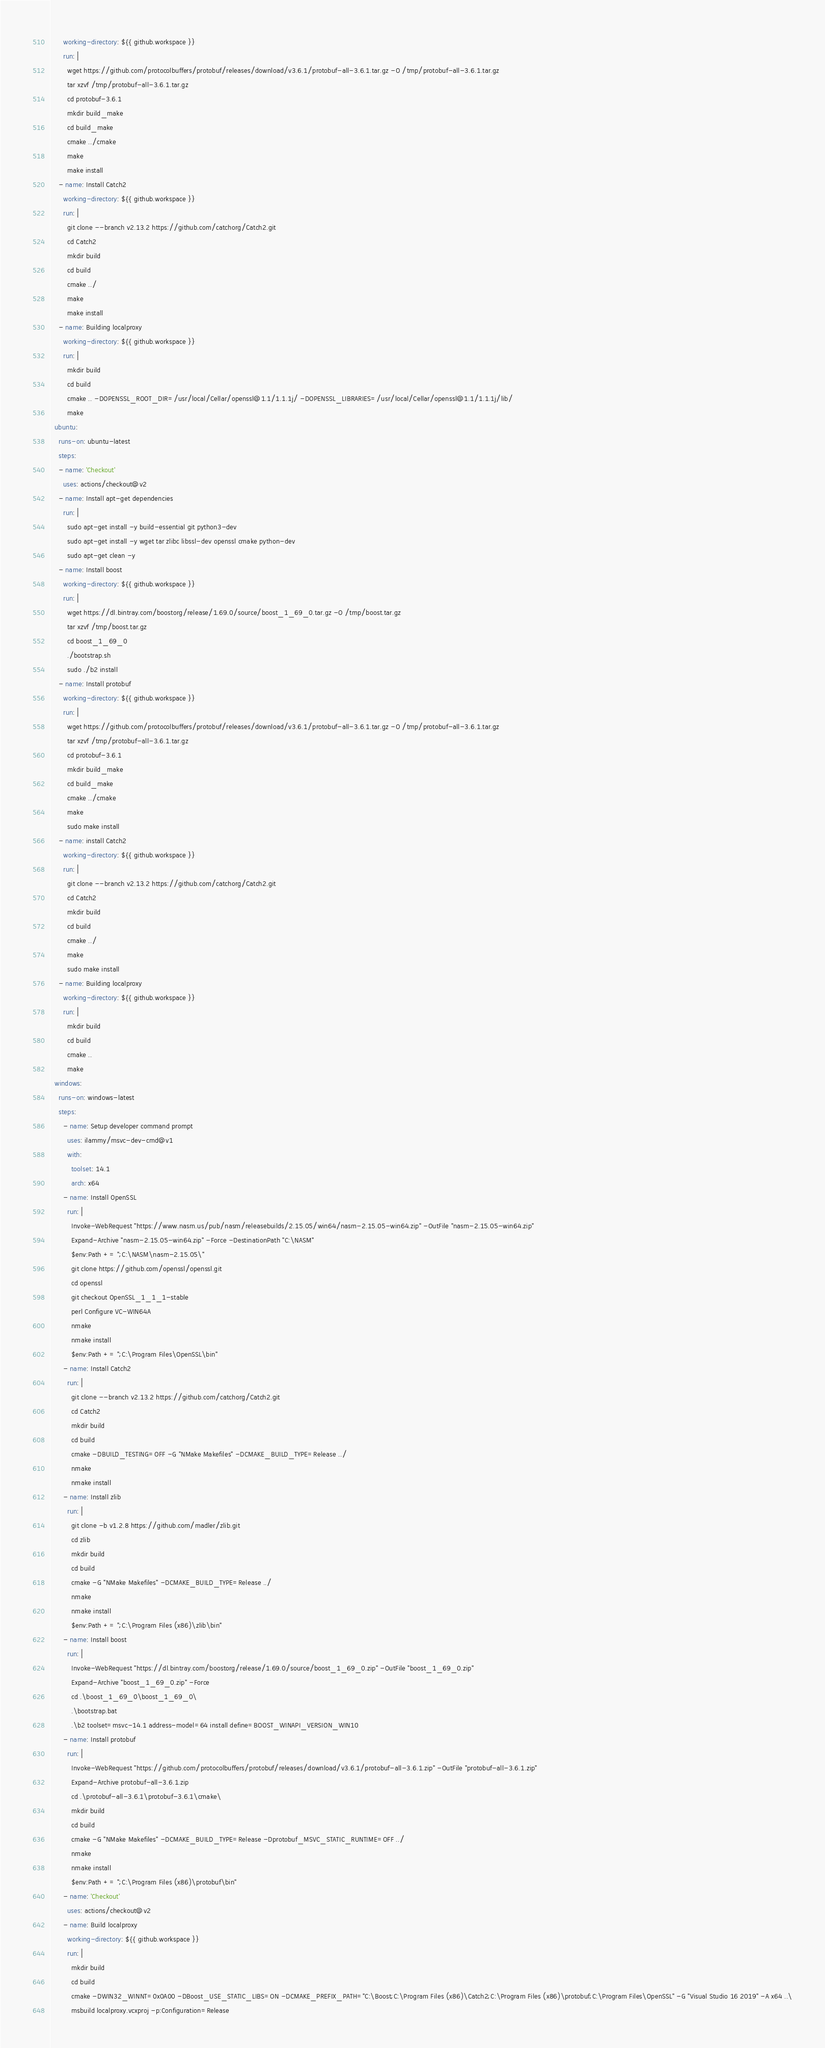Convert code to text. <code><loc_0><loc_0><loc_500><loc_500><_YAML_>      working-directory: ${{ github.workspace }}
      run: |
        wget https://github.com/protocolbuffers/protobuf/releases/download/v3.6.1/protobuf-all-3.6.1.tar.gz -O /tmp/protobuf-all-3.6.1.tar.gz
        tar xzvf /tmp/protobuf-all-3.6.1.tar.gz
        cd protobuf-3.6.1
        mkdir build_make
        cd build_make
        cmake ../cmake
        make
        make install
    - name: Install Catch2
      working-directory: ${{ github.workspace }}
      run: |
        git clone --branch v2.13.2 https://github.com/catchorg/Catch2.git
        cd Catch2
        mkdir build
        cd build
        cmake ../
        make
        make install
    - name: Building localproxy
      working-directory: ${{ github.workspace }}
      run: |
        mkdir build
        cd build
        cmake .. -DOPENSSL_ROOT_DIR=/usr/local/Cellar/openssl@1.1/1.1.1j/ -DOPENSSL_LIBRARIES=/usr/local/Cellar/openssl@1.1/1.1.1j/lib/
        make
  ubuntu:
    runs-on: ubuntu-latest
    steps:
    - name: 'Checkout'
      uses: actions/checkout@v2
    - name: Install apt-get dependencies
      run: |
        sudo apt-get install -y build-essential git python3-dev
        sudo apt-get install -y wget tar zlibc libssl-dev openssl cmake python-dev
        sudo apt-get clean -y
    - name: Install boost
      working-directory: ${{ github.workspace }}
      run: |
        wget https://dl.bintray.com/boostorg/release/1.69.0/source/boost_1_69_0.tar.gz -O /tmp/boost.tar.gz
        tar xzvf /tmp/boost.tar.gz
        cd boost_1_69_0
        ./bootstrap.sh
        sudo ./b2 install
    - name: Install protobuf
      working-directory: ${{ github.workspace }}
      run: |
        wget https://github.com/protocolbuffers/protobuf/releases/download/v3.6.1/protobuf-all-3.6.1.tar.gz -O /tmp/protobuf-all-3.6.1.tar.gz
        tar xzvf /tmp/protobuf-all-3.6.1.tar.gz
        cd protobuf-3.6.1
        mkdir build_make
        cd build_make
        cmake ../cmake
        make
        sudo make install
    - name: install Catch2
      working-directory: ${{ github.workspace }}
      run: |
        git clone --branch v2.13.2 https://github.com/catchorg/Catch2.git
        cd Catch2
        mkdir build
        cd build
        cmake ../
        make
        sudo make install
    - name: Building localproxy
      working-directory: ${{ github.workspace }}
      run: |
        mkdir build
        cd build
        cmake ..
        make
  windows:
    runs-on: windows-latest
    steps:
      - name: Setup developer command prompt
        uses: ilammy/msvc-dev-cmd@v1
        with:
          toolset: 14.1
          arch: x64
      - name: Install OpenSSL
        run: |
          Invoke-WebRequest "https://www.nasm.us/pub/nasm/releasebuilds/2.15.05/win64/nasm-2.15.05-win64.zip" -OutFile "nasm-2.15.05-win64.zip"
          Expand-Archive "nasm-2.15.05-win64.zip" -Force -DestinationPath "C:\NASM"
          $env:Path += ";C:\NASM\nasm-2.15.05\"
          git clone https://github.com/openssl/openssl.git
          cd openssl
          git checkout OpenSSL_1_1_1-stable
          perl Configure VC-WIN64A
          nmake
          nmake install
          $env:Path += ";C:\Program Files\OpenSSL\bin"
      - name: Install Catch2
        run: |
          git clone --branch v2.13.2 https://github.com/catchorg/Catch2.git
          cd Catch2
          mkdir build
          cd build
          cmake -DBUILD_TESTING=OFF -G "NMake Makefiles" -DCMAKE_BUILD_TYPE=Release ../
          nmake
          nmake install
      - name: Install zlib
        run: |
          git clone -b v1.2.8 https://github.com/madler/zlib.git
          cd zlib
          mkdir build
          cd build
          cmake -G "NMake Makefiles" -DCMAKE_BUILD_TYPE=Release ../
          nmake
          nmake install
          $env:Path += ";C:\Program Files (x86)\zlib\bin"
      - name: Install boost
        run: |
          Invoke-WebRequest "https://dl.bintray.com/boostorg/release/1.69.0/source/boost_1_69_0.zip" -OutFile "boost_1_69_0.zip"
          Expand-Archive "boost_1_69_0.zip" -Force
          cd .\boost_1_69_0\boost_1_69_0\
          .\bootstrap.bat
          .\b2 toolset=msvc-14.1 address-model=64 install define=BOOST_WINAPI_VERSION_WIN10
      - name: Install protobuf
        run: |
          Invoke-WebRequest "https://github.com/protocolbuffers/protobuf/releases/download/v3.6.1/protobuf-all-3.6.1.zip" -OutFile "protobuf-all-3.6.1.zip"
          Expand-Archive protobuf-all-3.6.1.zip
          cd .\protobuf-all-3.6.1\protobuf-3.6.1\cmake\
          mkdir build
          cd build
          cmake -G "NMake Makefiles" -DCMAKE_BUILD_TYPE=Release -Dprotobuf_MSVC_STATIC_RUNTIME=OFF ../
          nmake
          nmake install
          $env:Path += ";C:\Program Files (x86)\protobuf\bin"
      - name: 'Checkout'
        uses: actions/checkout@v2
      - name: Build localproxy 
        working-directory: ${{ github.workspace }}
        run: |
          mkdir build
          cd build
          cmake -DWIN32_WINNT=0x0A00 -DBoost_USE_STATIC_LIBS=ON -DCMAKE_PREFIX_PATH="C:\Boost;C:\Program Files (x86)\Catch2;C:\Program Files (x86)\protobuf;C:\Program Files\OpenSSL" -G "Visual Studio 16 2019" -A x64 ..\
          msbuild localproxy.vcxproj -p:Configuration=Release
</code> 